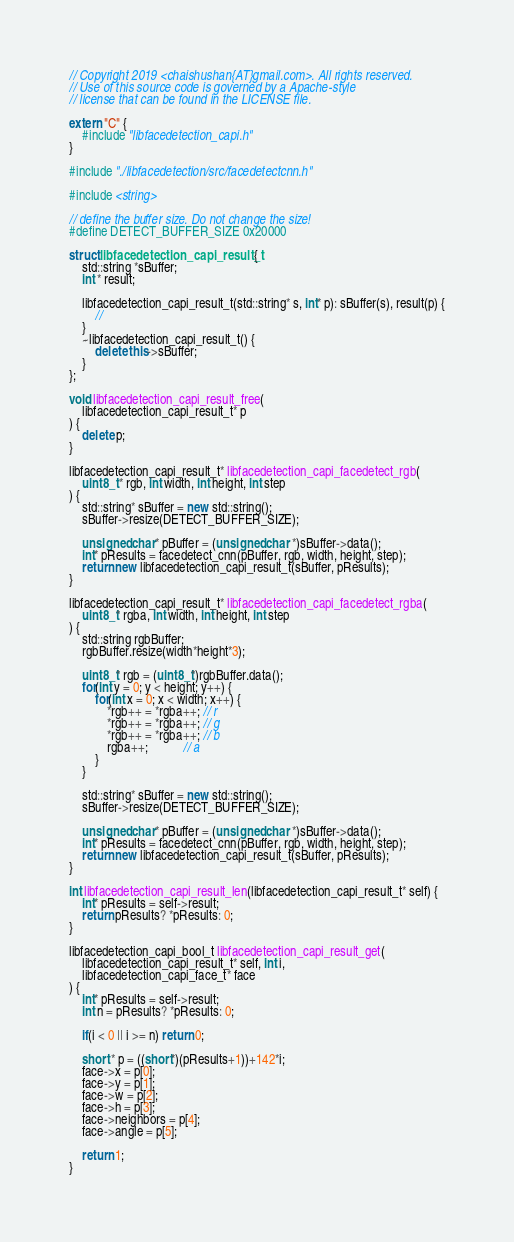Convert code to text. <code><loc_0><loc_0><loc_500><loc_500><_C++_>// Copyright 2019 <chaishushan{AT}gmail.com>. All rights reserved.
// Use of this source code is governed by a Apache-style
// license that can be found in the LICENSE file.

extern "C" {
	#include "libfacedetection_capi.h"
}

#include "./libfacedetection/src/facedetectcnn.h"

#include <string>

// define the buffer size. Do not change the size!
#define DETECT_BUFFER_SIZE 0x20000

struct libfacedetection_capi_result_t {
	std::string *sBuffer;
	int * result;

	libfacedetection_capi_result_t(std::string* s, int* p): sBuffer(s), result(p) {
		//
	}
	~libfacedetection_capi_result_t() {
		delete this->sBuffer;
	}
};

void libfacedetection_capi_result_free(
	libfacedetection_capi_result_t* p
) {
	delete p;
}

libfacedetection_capi_result_t* libfacedetection_capi_facedetect_rgb(
	uint8_t * rgb, int width, int height, int step
) {
	std::string* sBuffer = new std::string();
	sBuffer->resize(DETECT_BUFFER_SIZE);

	unsigned char* pBuffer = (unsigned char *)sBuffer->data();
	int* pResults = facedetect_cnn(pBuffer, rgb, width, height, step);
	return new libfacedetection_capi_result_t(sBuffer, pResults);
}

libfacedetection_capi_result_t* libfacedetection_capi_facedetect_rgba(
	uint8_t* rgba, int width, int height, int step
) {
	std::string rgbBuffer;
	rgbBuffer.resize(width*height*3);

	uint8_t* rgb = (uint8_t*)rgbBuffer.data();
	for(int y = 0; y < height; y++) {
		for(int x = 0; x < width; x++) {
			*rgb++ = *rgba++; // r
			*rgb++ = *rgba++; // g
			*rgb++ = *rgba++; // b
			rgba++;           // a
		}
	}

	std::string* sBuffer = new std::string();
	sBuffer->resize(DETECT_BUFFER_SIZE);

	unsigned char* pBuffer = (unsigned char *)sBuffer->data();
	int* pResults = facedetect_cnn(pBuffer, rgb, width, height, step);
	return new libfacedetection_capi_result_t(sBuffer, pResults);
}

int libfacedetection_capi_result_len(libfacedetection_capi_result_t* self) {
	int* pResults = self->result;
	return pResults? *pResults: 0;
}

libfacedetection_capi_bool_t libfacedetection_capi_result_get(
	libfacedetection_capi_result_t* self, int i,
	libfacedetection_capi_face_t* face
) {
	int* pResults = self->result;
	int n = pResults? *pResults: 0;

	if(i < 0 || i >= n) return 0;

	short * p = ((short*)(pResults+1))+142*i;
	face->x = p[0];
	face->y = p[1];
	face->w = p[2];
	face->h = p[3];
	face->neighbors = p[4];
	face->angle = p[5];

	return 1;
}
</code> 